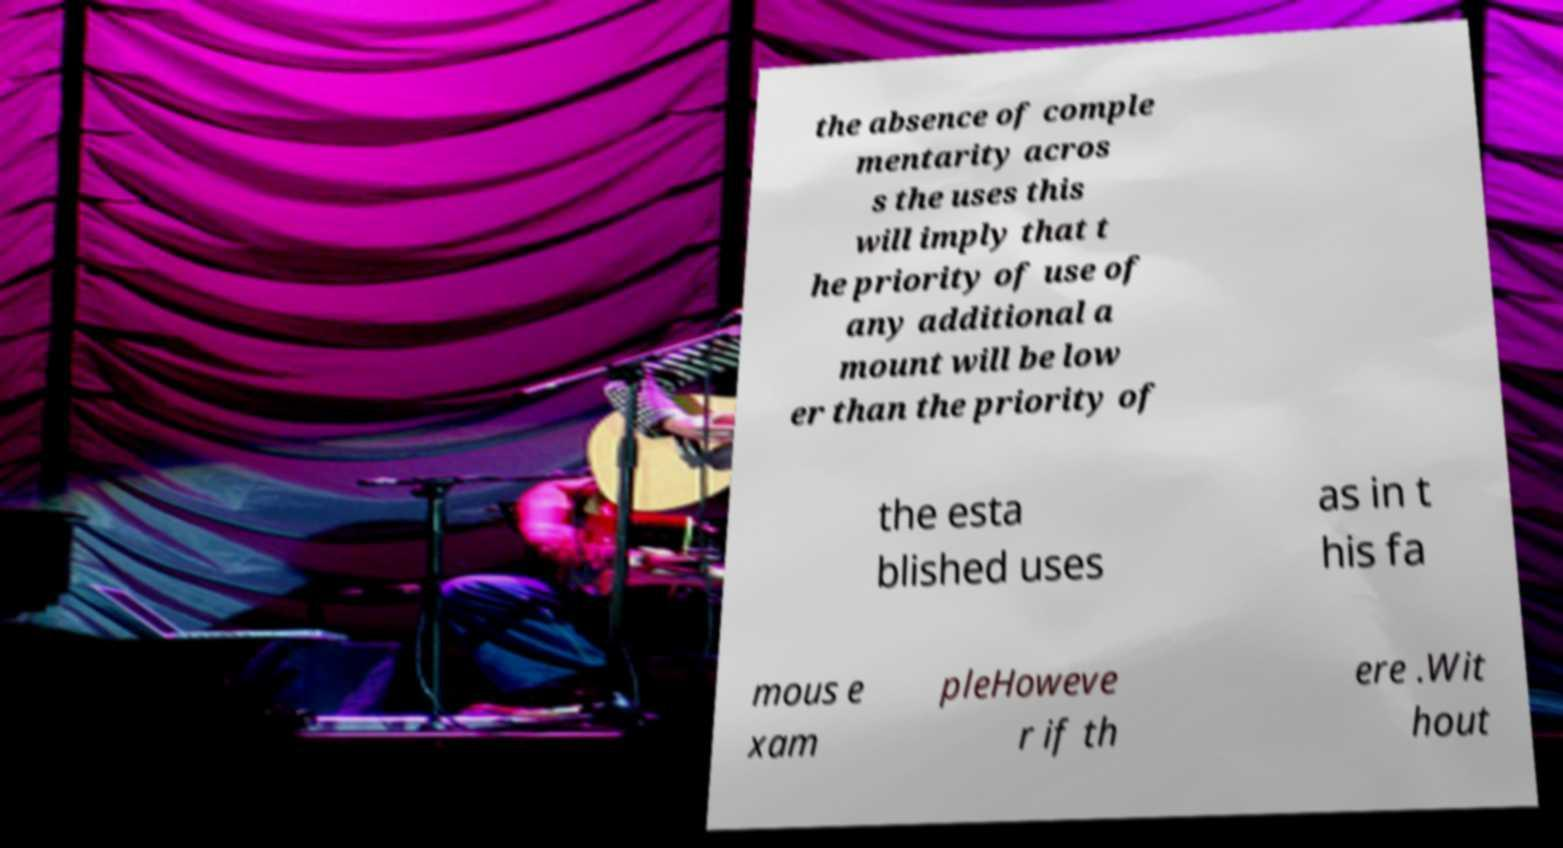I need the written content from this picture converted into text. Can you do that? the absence of comple mentarity acros s the uses this will imply that t he priority of use of any additional a mount will be low er than the priority of the esta blished uses as in t his fa mous e xam pleHoweve r if th ere .Wit hout 